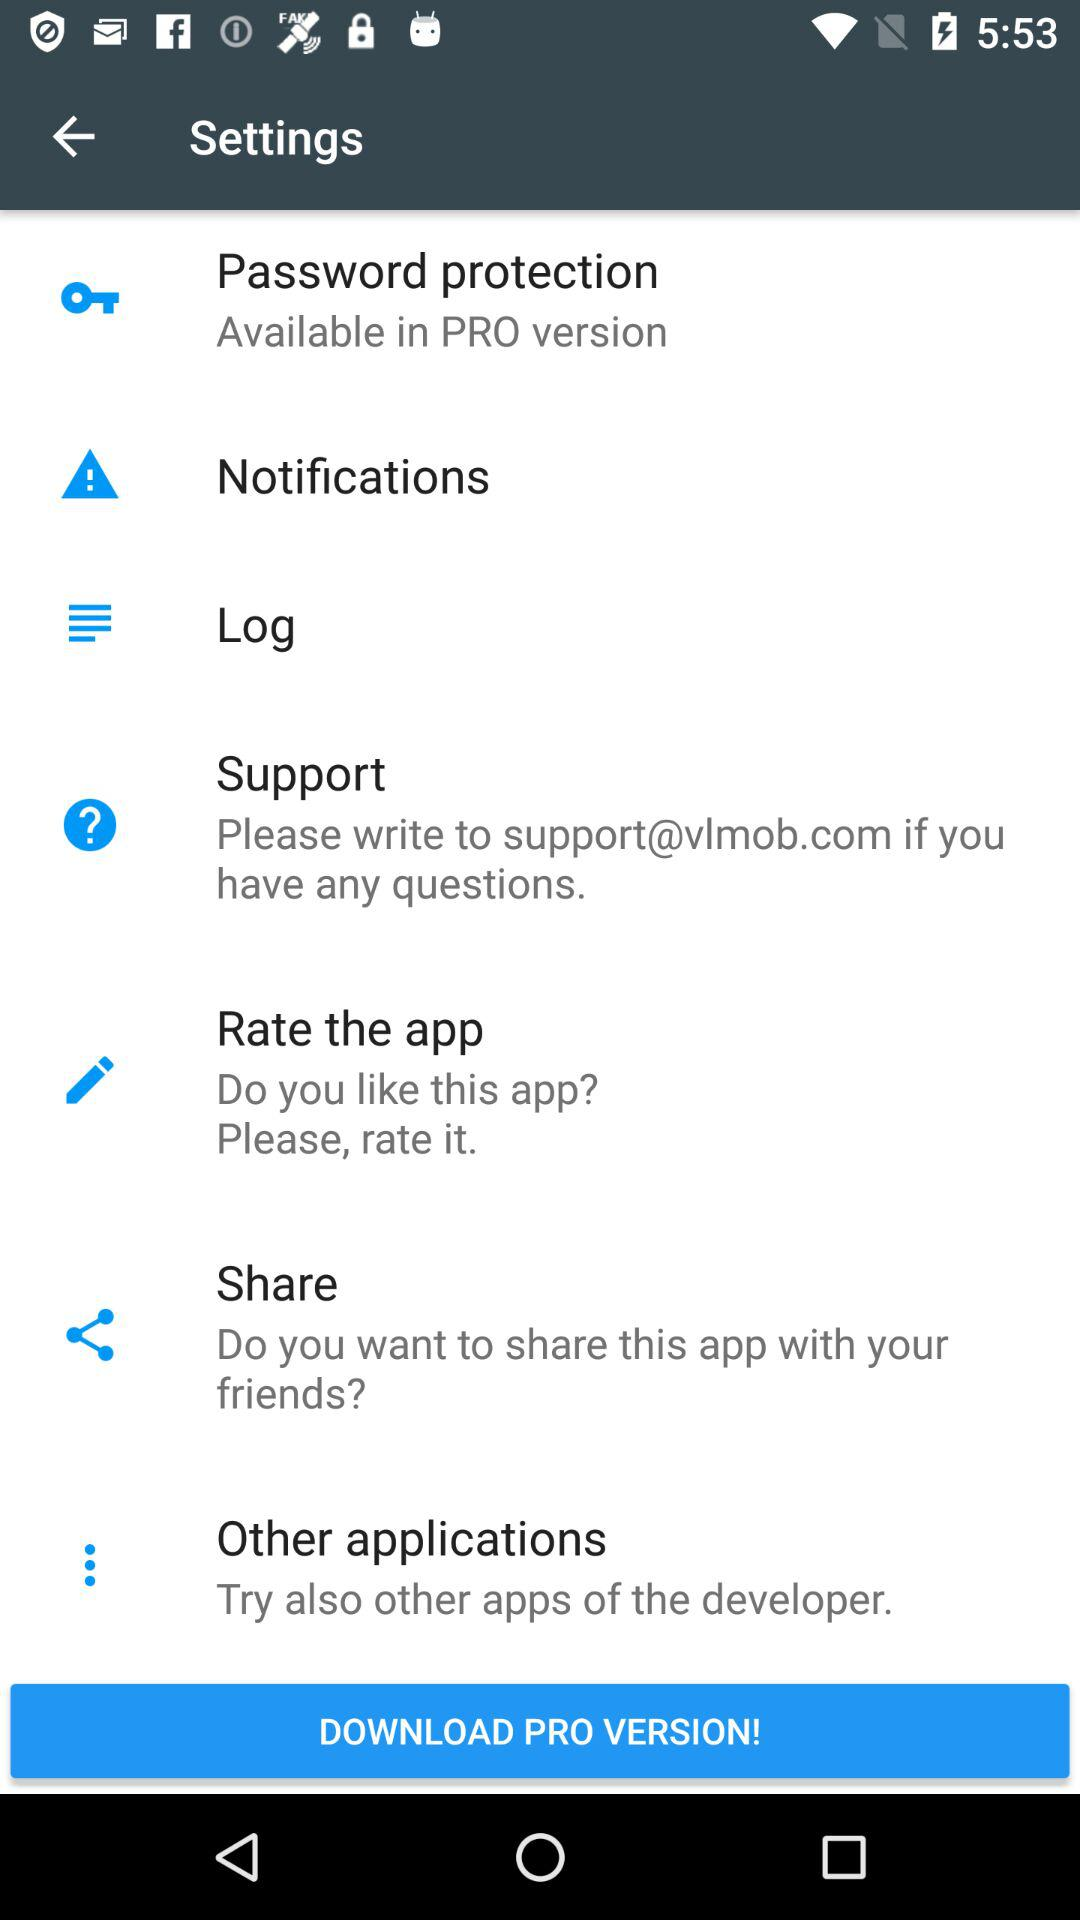In which version is password protection available? Password protection is available in the PRO version. 